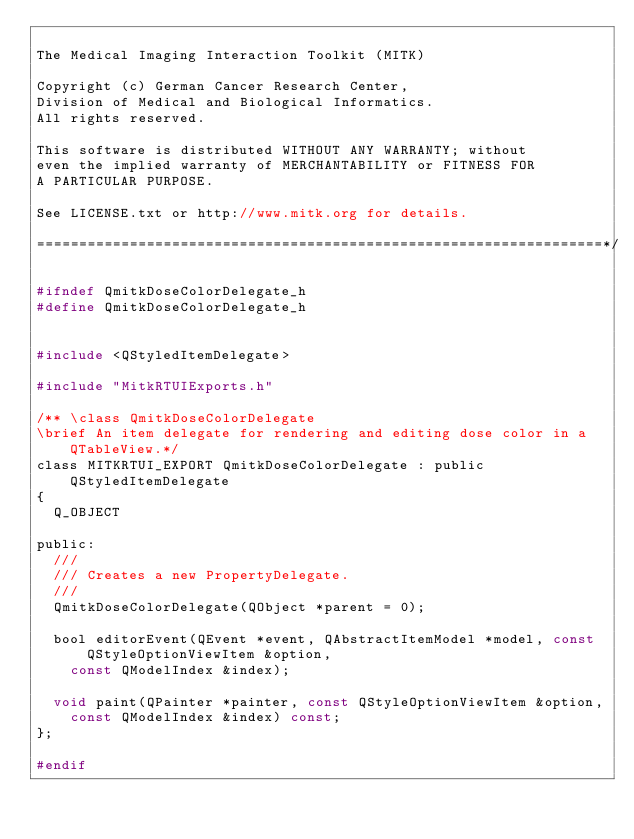Convert code to text. <code><loc_0><loc_0><loc_500><loc_500><_C_>
The Medical Imaging Interaction Toolkit (MITK)

Copyright (c) German Cancer Research Center,
Division of Medical and Biological Informatics.
All rights reserved.

This software is distributed WITHOUT ANY WARRANTY; without
even the implied warranty of MERCHANTABILITY or FITNESS FOR
A PARTICULAR PURPOSE.

See LICENSE.txt or http://www.mitk.org for details.

===================================================================*/

#ifndef QmitkDoseColorDelegate_h
#define QmitkDoseColorDelegate_h


#include <QStyledItemDelegate>

#include "MitkRTUIExports.h"

/** \class QmitkDoseColorDelegate
\brief An item delegate for rendering and editing dose color in a QTableView.*/
class MITKRTUI_EXPORT QmitkDoseColorDelegate : public QStyledItemDelegate
{
  Q_OBJECT

public:
  ///
  /// Creates a new PropertyDelegate.
  ///
  QmitkDoseColorDelegate(QObject *parent = 0);

  bool editorEvent(QEvent *event, QAbstractItemModel *model, const QStyleOptionViewItem &option,
    const QModelIndex &index);

  void paint(QPainter *painter, const QStyleOptionViewItem &option,
    const QModelIndex &index) const;
};

#endif
</code> 